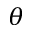Convert formula to latex. <formula><loc_0><loc_0><loc_500><loc_500>\theta</formula> 